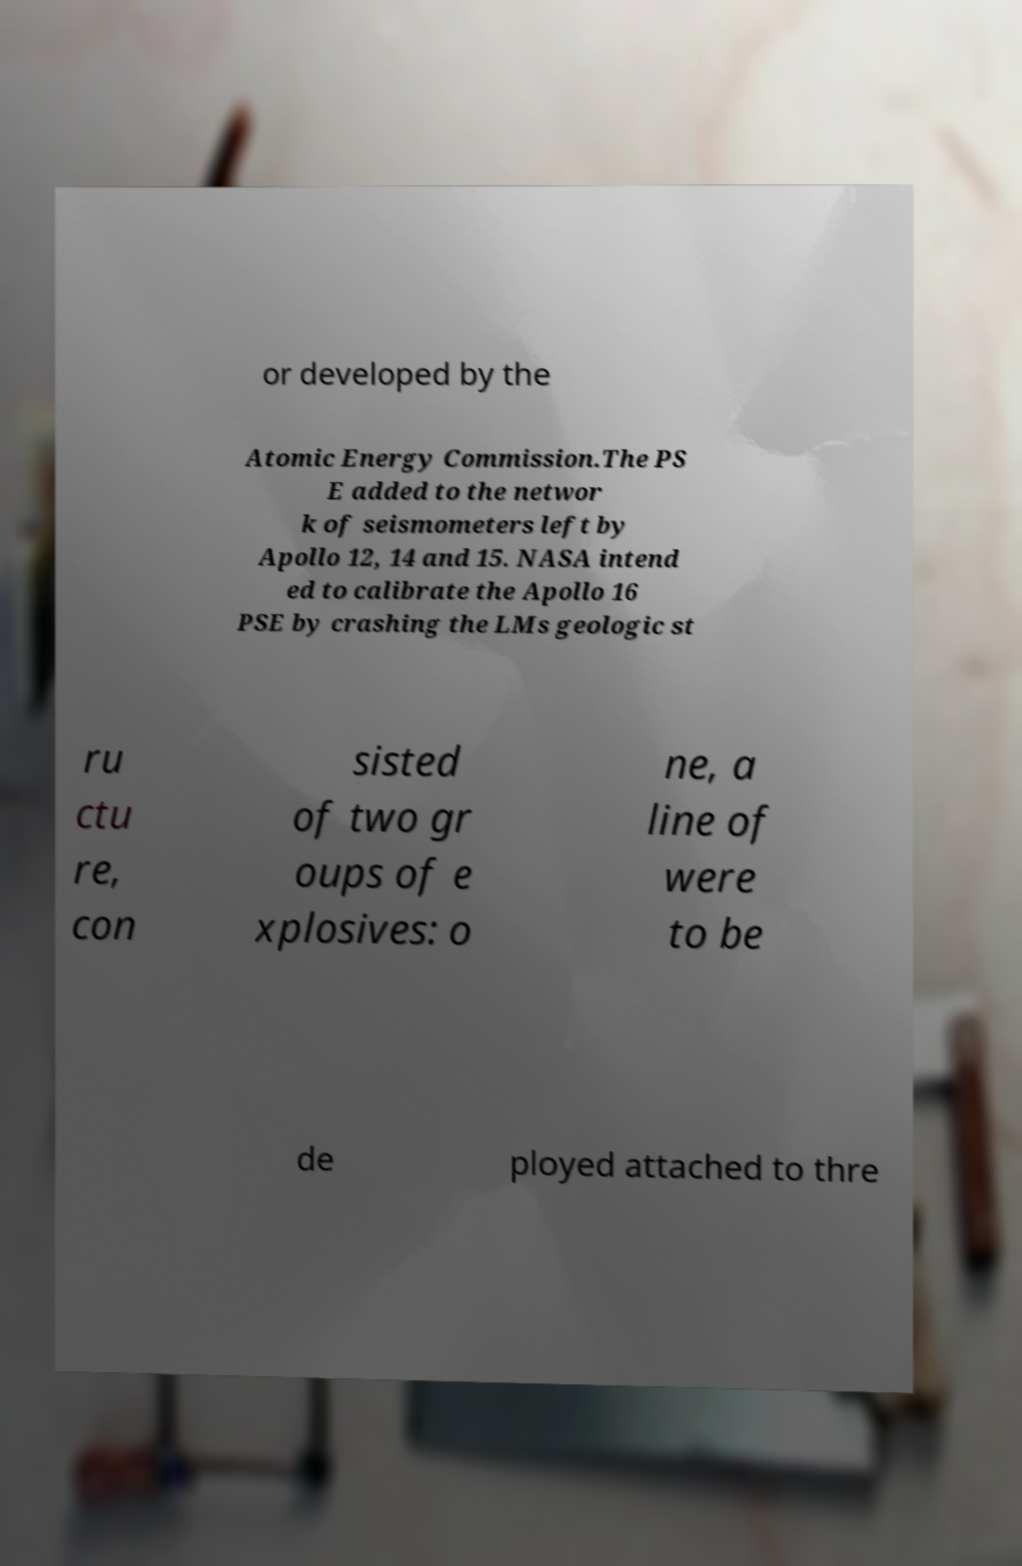There's text embedded in this image that I need extracted. Can you transcribe it verbatim? or developed by the Atomic Energy Commission.The PS E added to the networ k of seismometers left by Apollo 12, 14 and 15. NASA intend ed to calibrate the Apollo 16 PSE by crashing the LMs geologic st ru ctu re, con sisted of two gr oups of e xplosives: o ne, a line of were to be de ployed attached to thre 